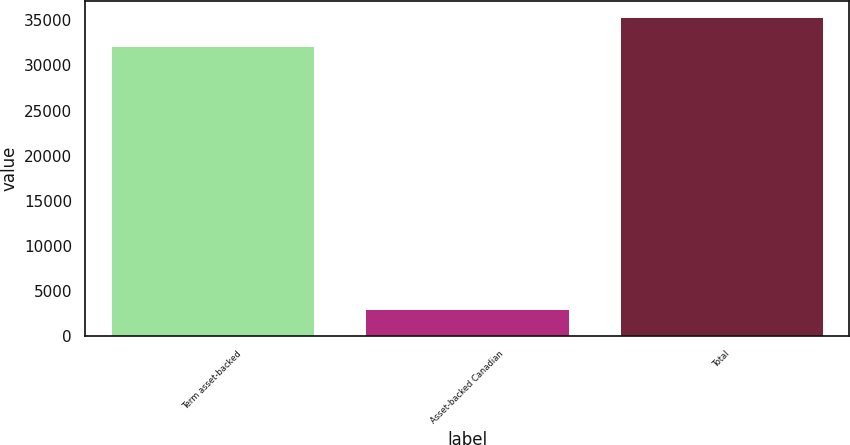Convert chart. <chart><loc_0><loc_0><loc_500><loc_500><bar_chart><fcel>Term asset-backed<fcel>Asset-backed Canadian<fcel>Total<nl><fcel>32156<fcel>2965<fcel>35371.6<nl></chart> 